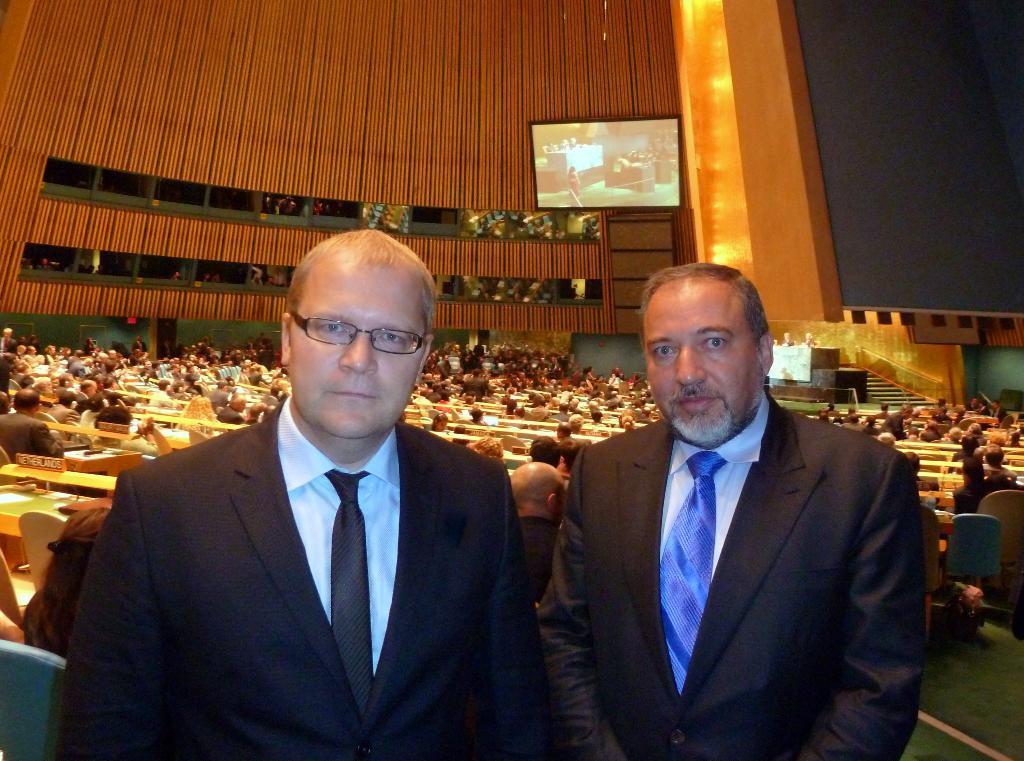Please provide a concise description of this image. In this image, there are a few people. We can see the ground. We can see some chairs. We can see some stairs. We can see the wall and a television. We can see some pillars. 